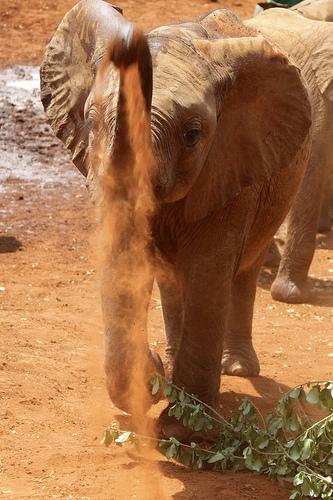Identify any secondary animals in the image and their relative positions to the main subject. There is a second elephant walking behind the main elephant and another dirty baby elephant in the background. Mention a specific interaction between the elephant and its environment in the image. The elephant's trunk picks up branches to eat from the ground. Estimate the number of elephants in the image. There are at least three elephants in this image. Examine the image and analyze the quality aspect of it, like the clarity of subjects and focus on the main object. The image presents a clear focus on the main elephant, capturing intricate details like its big ears and eyelashes, while also maintaining the clarity of the surrounding environment. In the image, point out any specific features regarding the anatomy of the main subject. The main elephant has big ears, long eyelashes, eyes looking down at the ground, and a long trunk full of dust. What animal is the main focus of the image and what is it doing? An elephant is the main focus and it is playing with dust and picking up dirt using its trunk. Providing a single sentence, describe the emotion or sentiment of the scene in the image. The image conveys a sense of peaceful curiosity as the elephant casually interacts with its surrounding environment. How might you describe the depicted terrain in this image? The terrain appears to be dry and features areas of brown dirt, rocks, and scattered leaves. Mention two body parts of the elephant that play a role in interaction with other objects in this image. The elephant's trunk and feet interact with dirt and branches on the ground. List three details or objects related to the ground in the image. There are wet and dry patches of dirt, leaves, and rocks on the ground. Try to locate the mysterious cave entrance located somewhere in the image. No, it's not mentioned in the image. Where is the tree that provides shade for the elephants? No trees are described in the image, only branches on the ground are mentioned. Can you find the hidden river flowing through the scene? In the scene, there does not appear to be any river or water source present. 